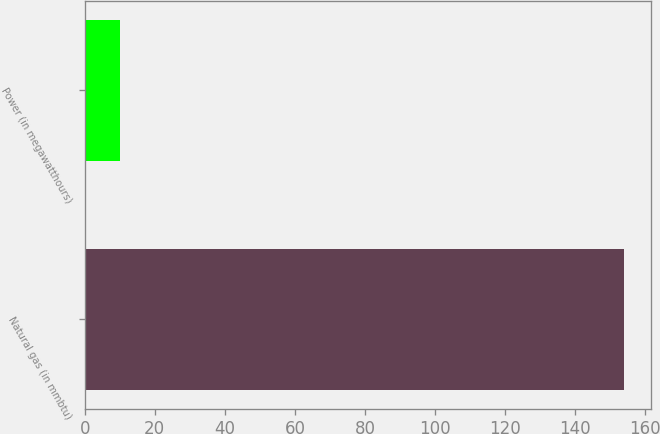<chart> <loc_0><loc_0><loc_500><loc_500><bar_chart><fcel>Natural gas (in mmbtu)<fcel>Power (in megawatthours)<nl><fcel>154<fcel>10<nl></chart> 